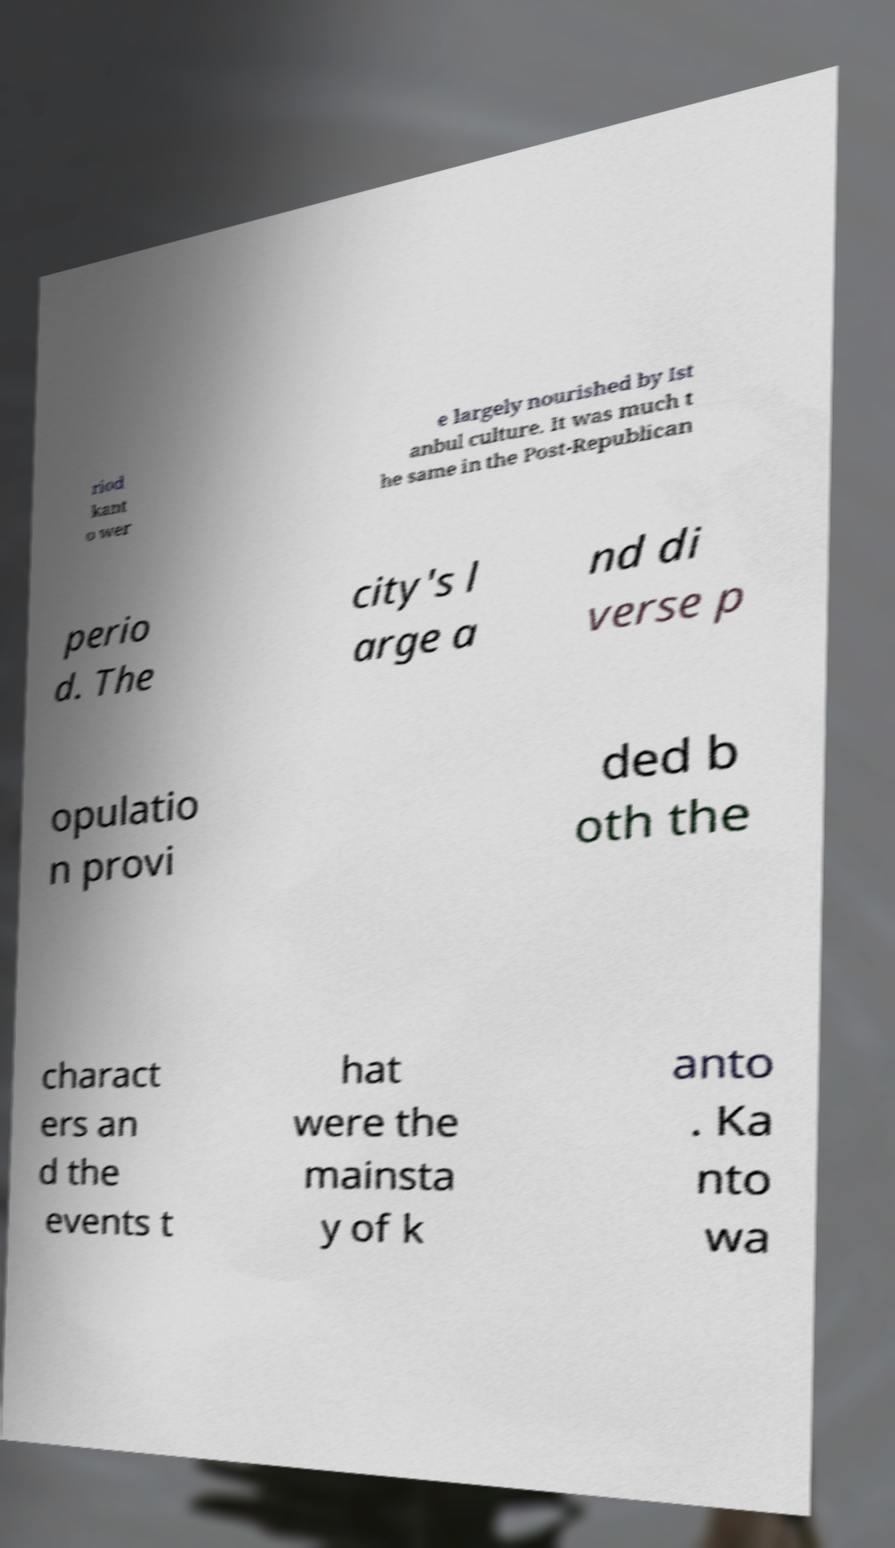Please read and relay the text visible in this image. What does it say? riod kant o wer e largely nourished by Ist anbul culture. It was much t he same in the Post-Republican perio d. The city's l arge a nd di verse p opulatio n provi ded b oth the charact ers an d the events t hat were the mainsta y of k anto . Ka nto wa 